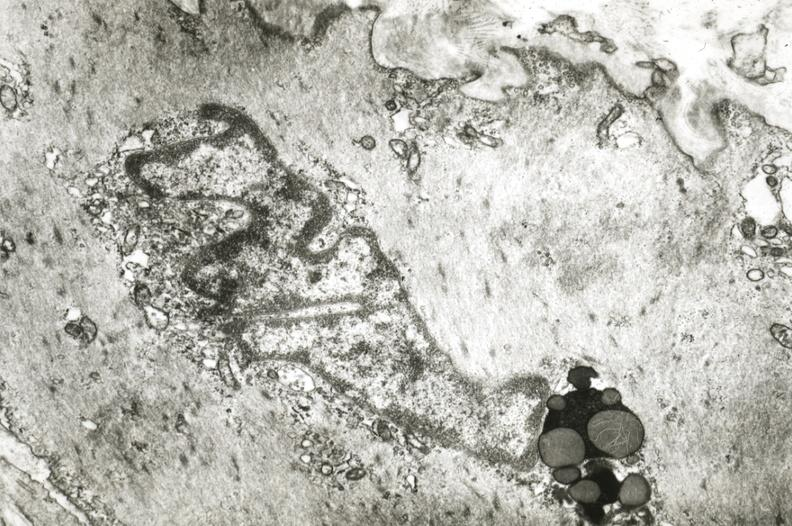what is present?
Answer the question using a single word or phrase. Coronary artery 